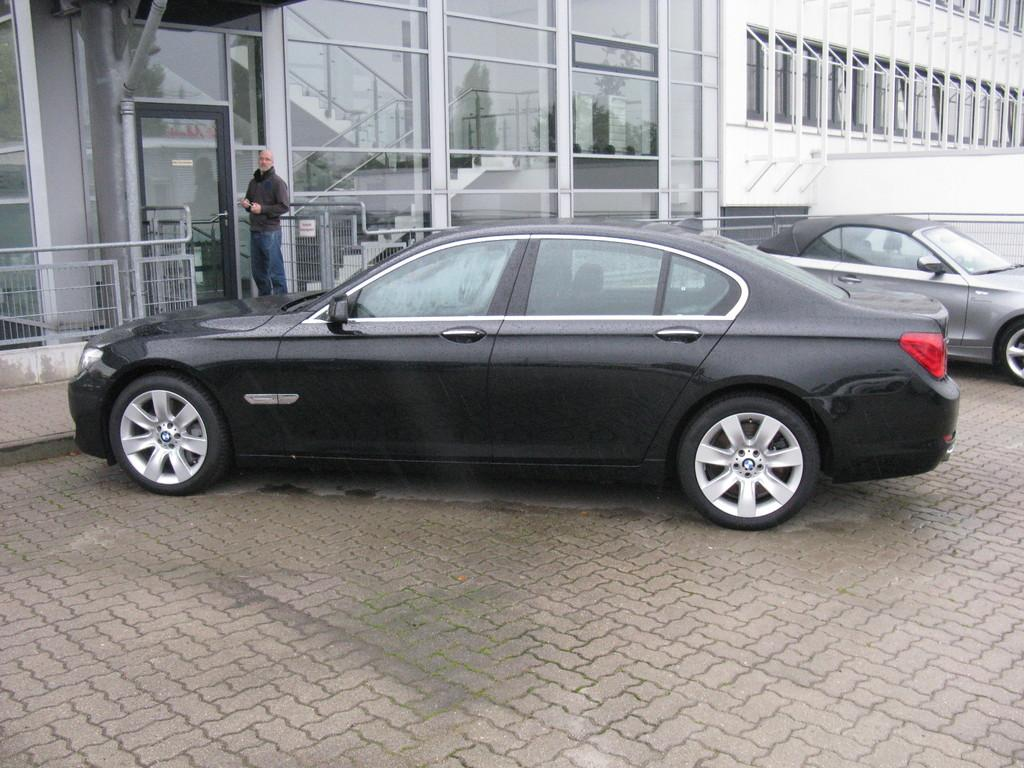What is located in the middle of the image? There are vehicles in the middle of the image. What is the man in the image doing? The man is standing behind the vehicles. What type of barrier is visible in the image? There is fencing visible in the image. What can be seen in the background of the image? There are buildings at the top of the image. How many beds are visible in the image? There are no beds present in the image. What type of cracker is the man eating in the image? There is no cracker present in the image, and the man is not eating anything. 